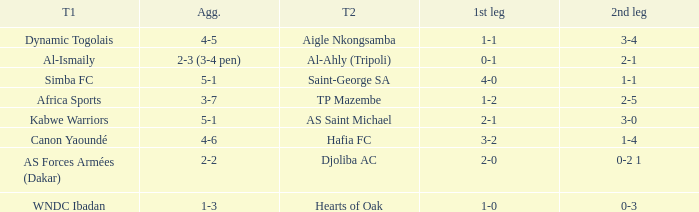What team played against Hafia FC (team 2)? Canon Yaoundé. 